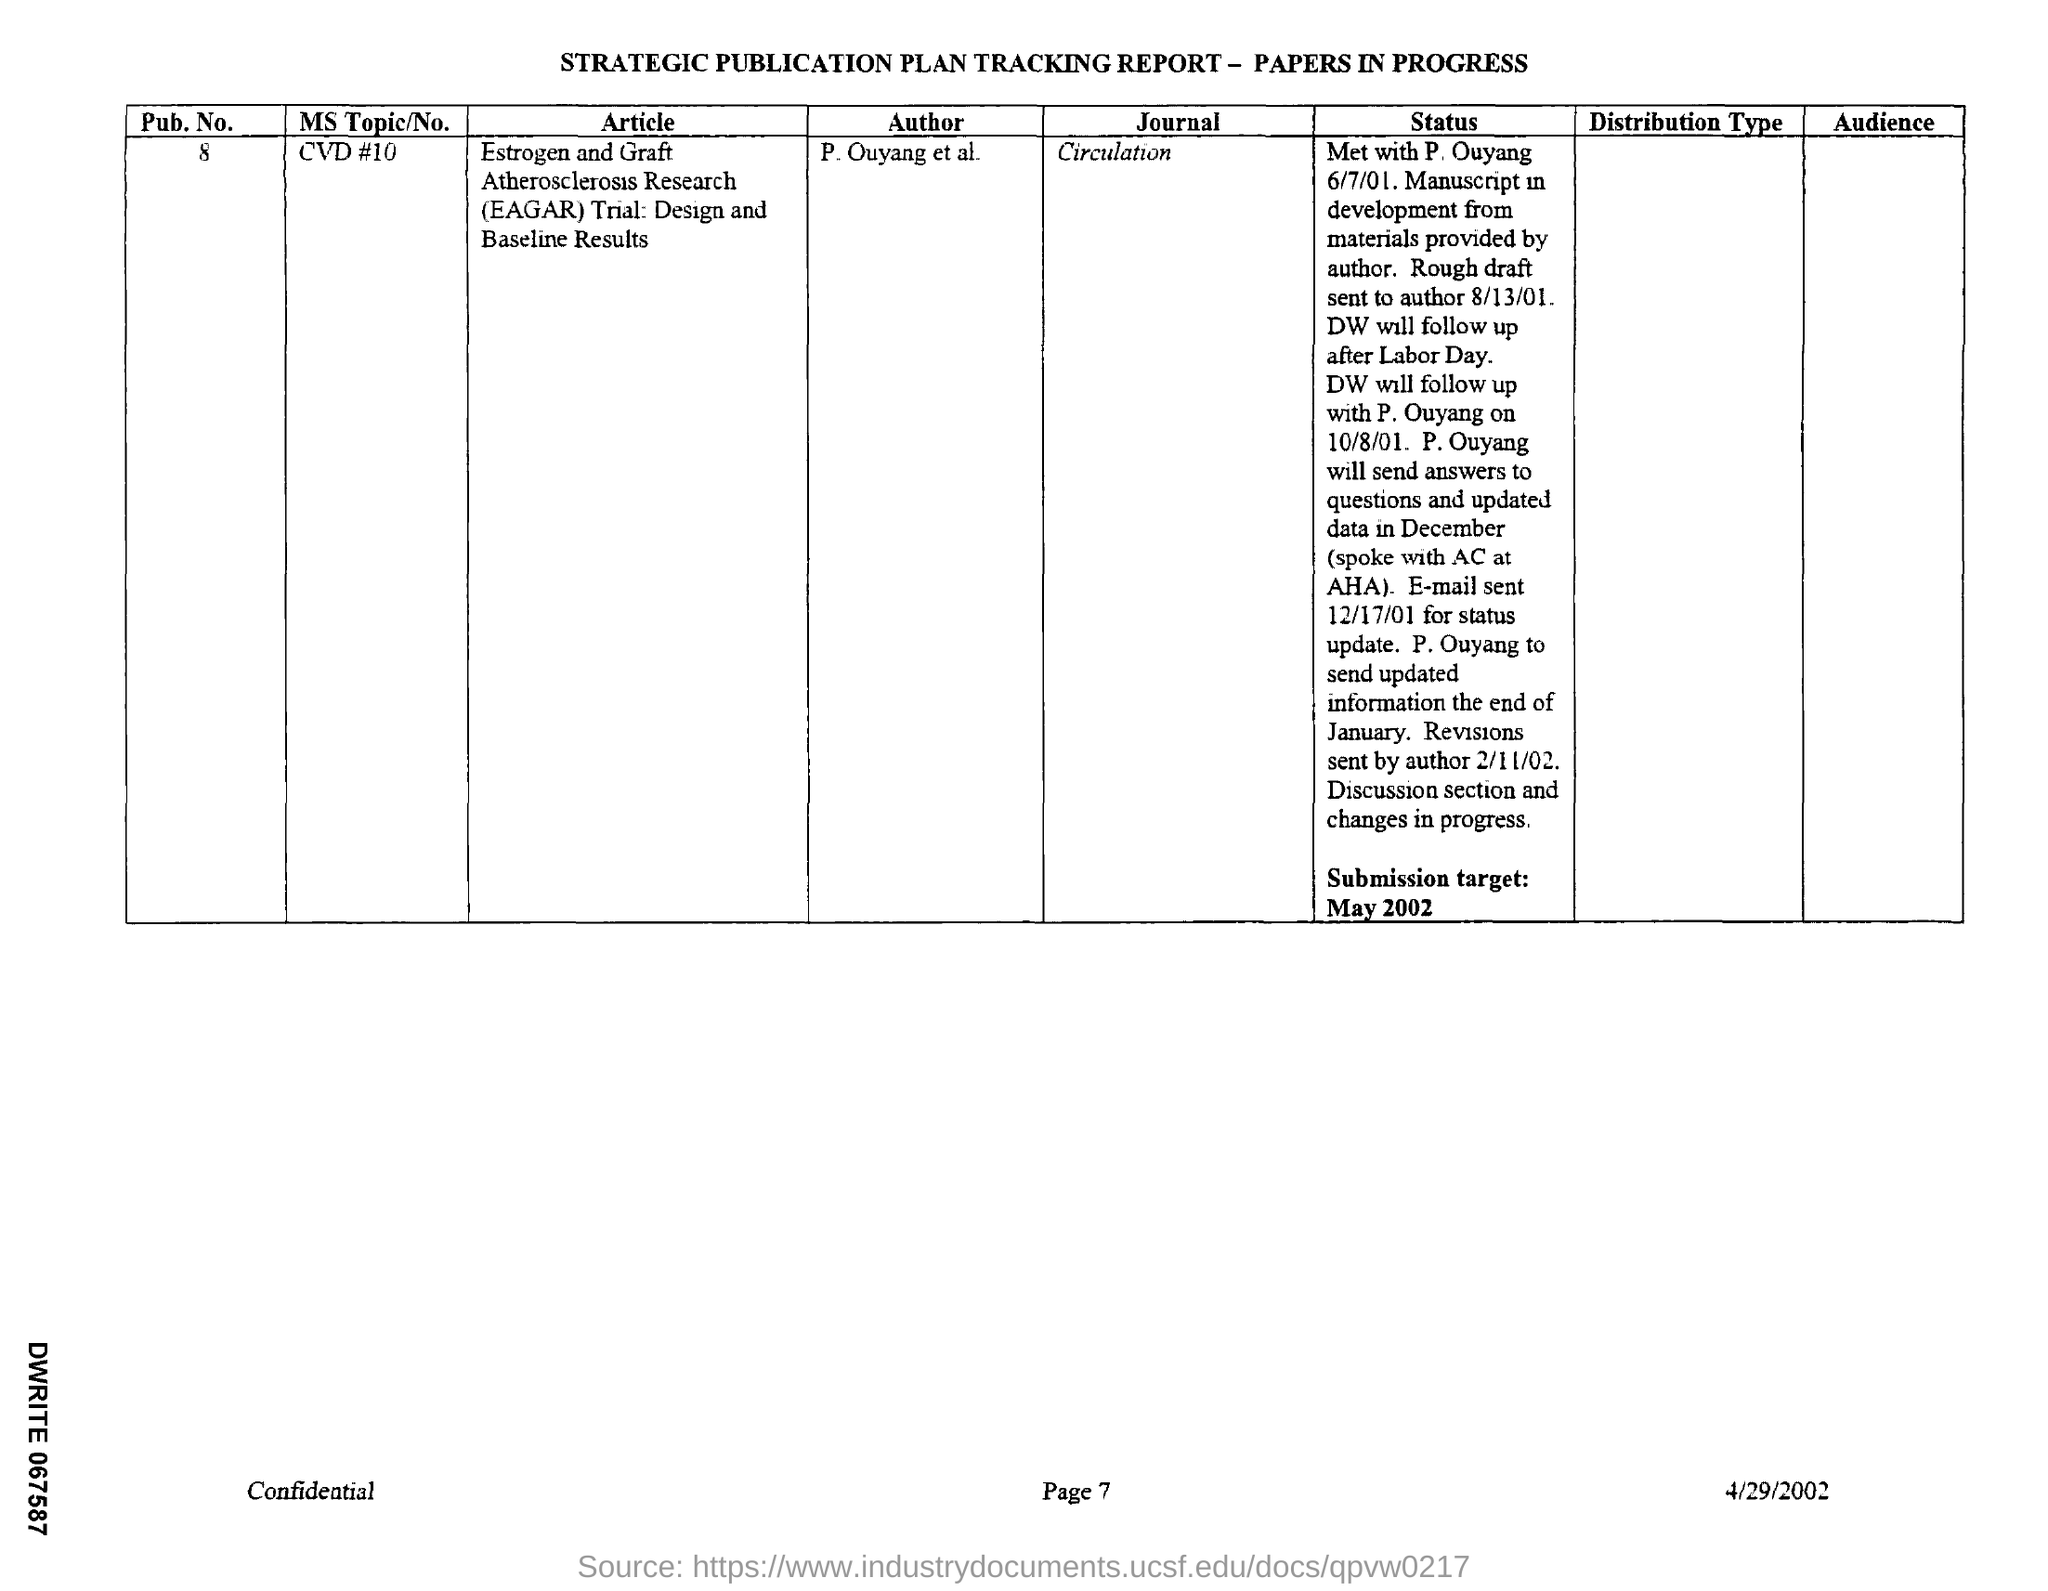Outline some significant characteristics in this image. The MS Topic/No. is CVD #10. The author of this text is P. Ouyang, along with other individuals who are listed as co-authors. The journal is named "Circulation. The document indicates that the date mentioned is 4/29/2002. 